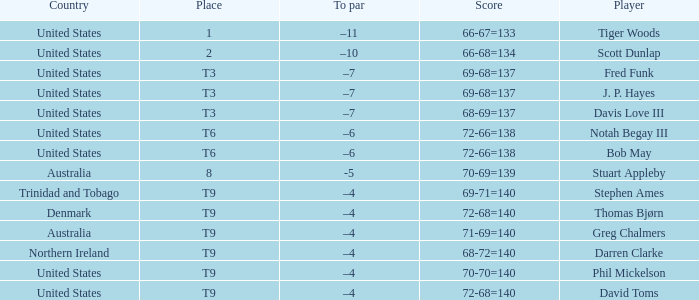What place did Bob May get when his score was 72-66=138? T6. 